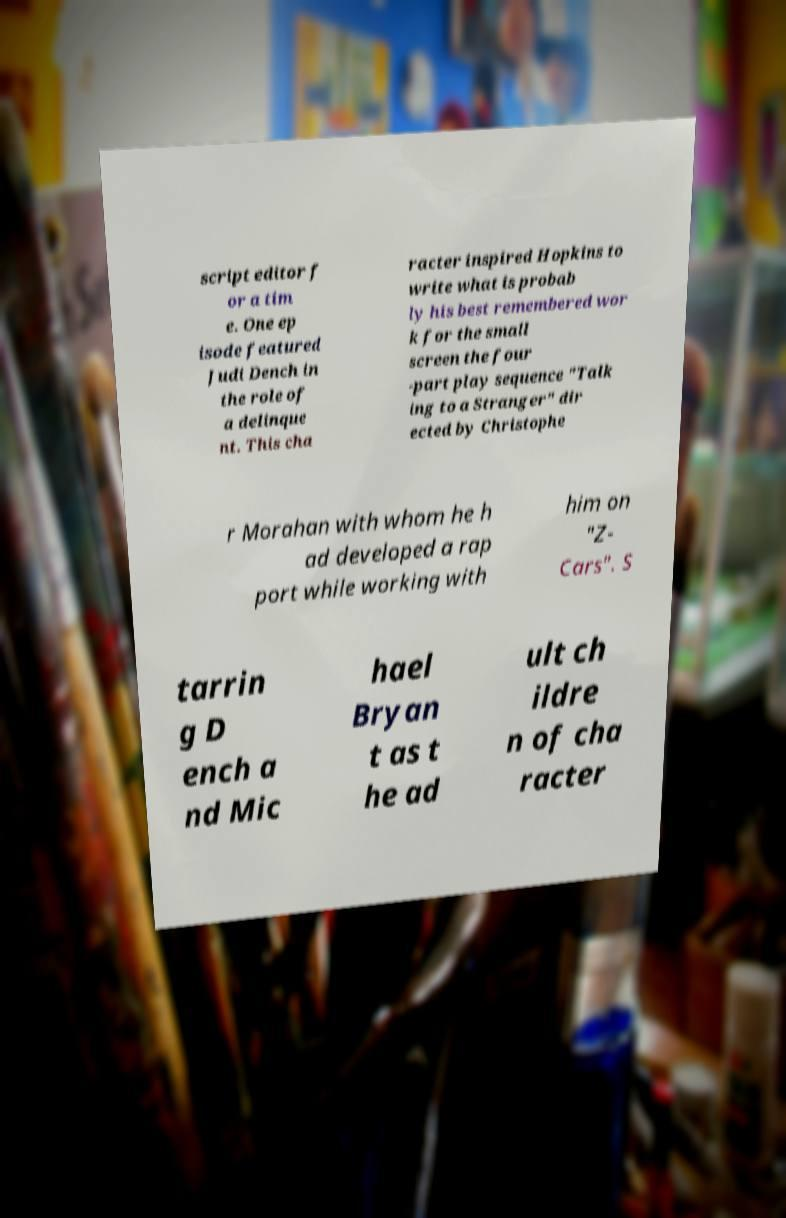I need the written content from this picture converted into text. Can you do that? script editor f or a tim e. One ep isode featured Judi Dench in the role of a delinque nt. This cha racter inspired Hopkins to write what is probab ly his best remembered wor k for the small screen the four -part play sequence "Talk ing to a Stranger" dir ected by Christophe r Morahan with whom he h ad developed a rap port while working with him on "Z- Cars". S tarrin g D ench a nd Mic hael Bryan t as t he ad ult ch ildre n of cha racter 